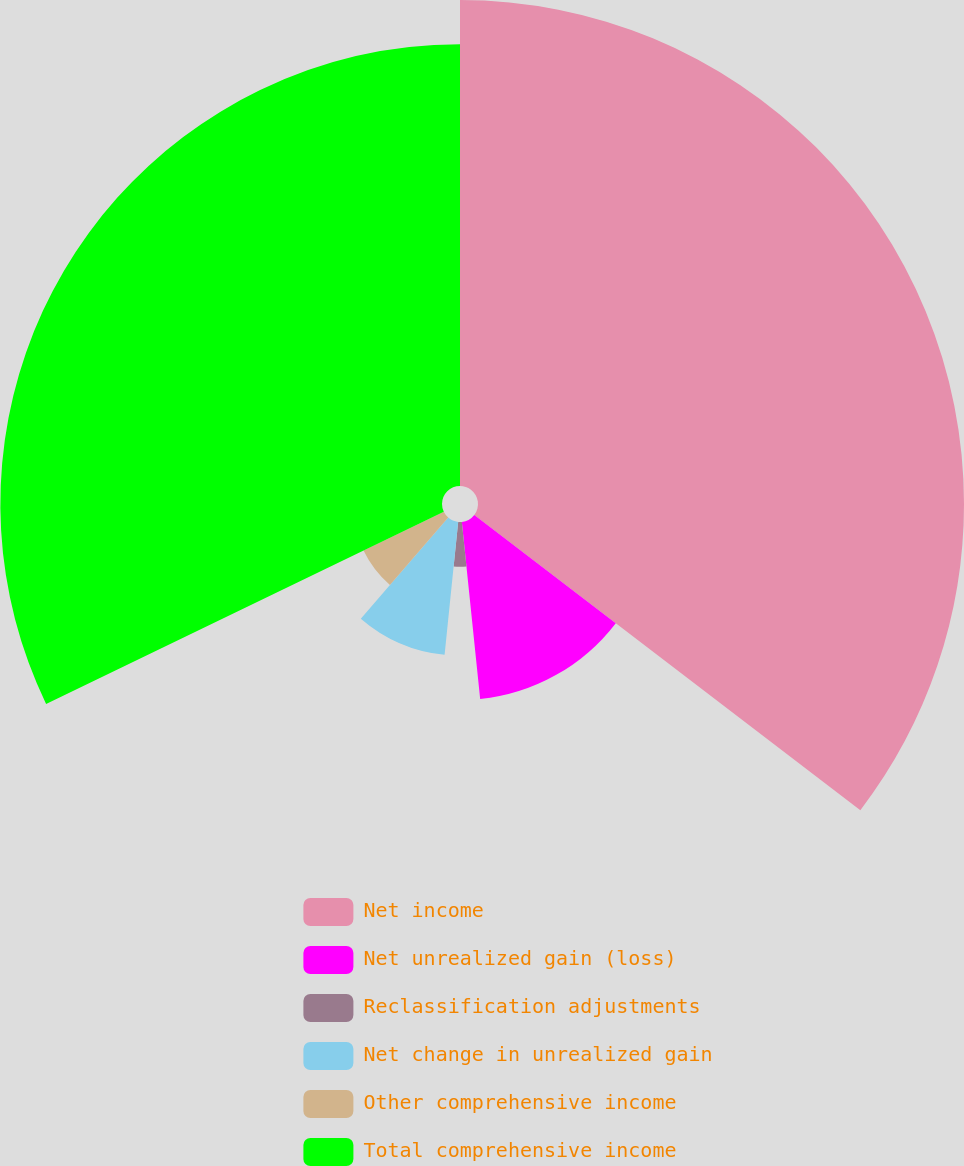Convert chart to OTSL. <chart><loc_0><loc_0><loc_500><loc_500><pie_chart><fcel>Net income<fcel>Net unrealized gain (loss)<fcel>Reclassification adjustments<fcel>Net change in unrealized gain<fcel>Other comprehensive income<fcel>Total comprehensive income<nl><fcel>35.39%<fcel>12.97%<fcel>3.26%<fcel>9.73%<fcel>6.49%<fcel>32.16%<nl></chart> 